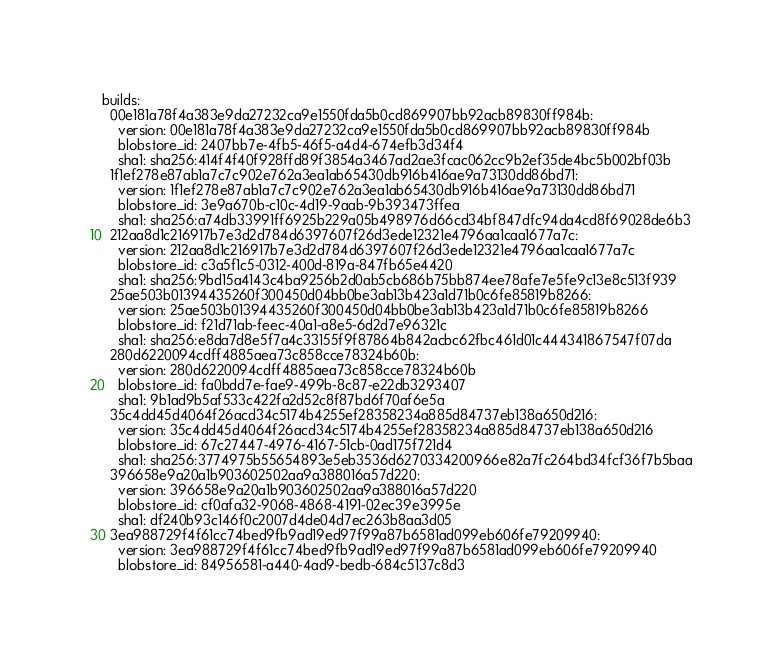<code> <loc_0><loc_0><loc_500><loc_500><_YAML_>builds:
  00e181a78f4a383e9da27232ca9e1550fda5b0cd869907bb92acb89830ff984b:
    version: 00e181a78f4a383e9da27232ca9e1550fda5b0cd869907bb92acb89830ff984b
    blobstore_id: 2407bb7e-4fb5-46f5-a4d4-674efb3d34f4
    sha1: sha256:414f4f40f928ffd89f3854a3467ad2ae3fcac062cc9b2ef35de4bc5b002bf03b
  1f1ef278e87ab1a7c7c902e762a3ea1ab65430db916b416ae9a73130dd86bd71:
    version: 1f1ef278e87ab1a7c7c902e762a3ea1ab65430db916b416ae9a73130dd86bd71
    blobstore_id: 3e9a670b-c10c-4d19-9aab-9b393473ffea
    sha1: sha256:a74db33991ff6925b229a05b498976d66cd34bf847dfc94da4cd8f69028de6b3
  212aa8d1c216917b7e3d2d784d6397607f26d3ede12321e4796aa1caa1677a7c:
    version: 212aa8d1c216917b7e3d2d784d6397607f26d3ede12321e4796aa1caa1677a7c
    blobstore_id: c3a5f1c5-0312-400d-819a-847fb65e4420
    sha1: sha256:9bd15a4143c4ba9256b2d0ab5cb686b75bb874ee78afe7e5fe9c13e8c513f939
  25ae503b01394435260f300450d04bb0be3ab13b423a1d71b0c6fe85819b8266:
    version: 25ae503b01394435260f300450d04bb0be3ab13b423a1d71b0c6fe85819b8266
    blobstore_id: f21d71ab-feec-40a1-a8e5-6d2d7e96321c
    sha1: sha256:e8da7d8e5f7a4c33155f9f87864b842acbc62fbc461d01c444341867547f07da
  280d6220094cdff4885aea73c858cce78324b60b:
    version: 280d6220094cdff4885aea73c858cce78324b60b
    blobstore_id: fa0bdd7e-fae9-499b-8c87-e22db3293407
    sha1: 9b1ad9b5af533c422fa2d52c8f87bd6f70af6e5a
  35c4dd45d4064f26acd34c5174b4255ef28358234a885d84737eb138a650d216:
    version: 35c4dd45d4064f26acd34c5174b4255ef28358234a885d84737eb138a650d216
    blobstore_id: 67c27447-4976-4167-51cb-0ad175f721d4
    sha1: sha256:3774975b55654893e5eb3536d6270334200966e82a7fc264bd34fcf36f7b5baa
  396658e9a20a1b903602502aa9a388016a57d220:
    version: 396658e9a20a1b903602502aa9a388016a57d220
    blobstore_id: cf0afa32-9068-4868-4191-02ec39e3995e
    sha1: df240b93c146f0c2007d4de04d7ec263b8aa3d05
  3ea988729f4f61cc74bed9fb9ad19ed97f99a87b6581ad099eb606fe79209940:
    version: 3ea988729f4f61cc74bed9fb9ad19ed97f99a87b6581ad099eb606fe79209940
    blobstore_id: 84956581-a440-4ad9-bedb-684c5137c8d3</code> 